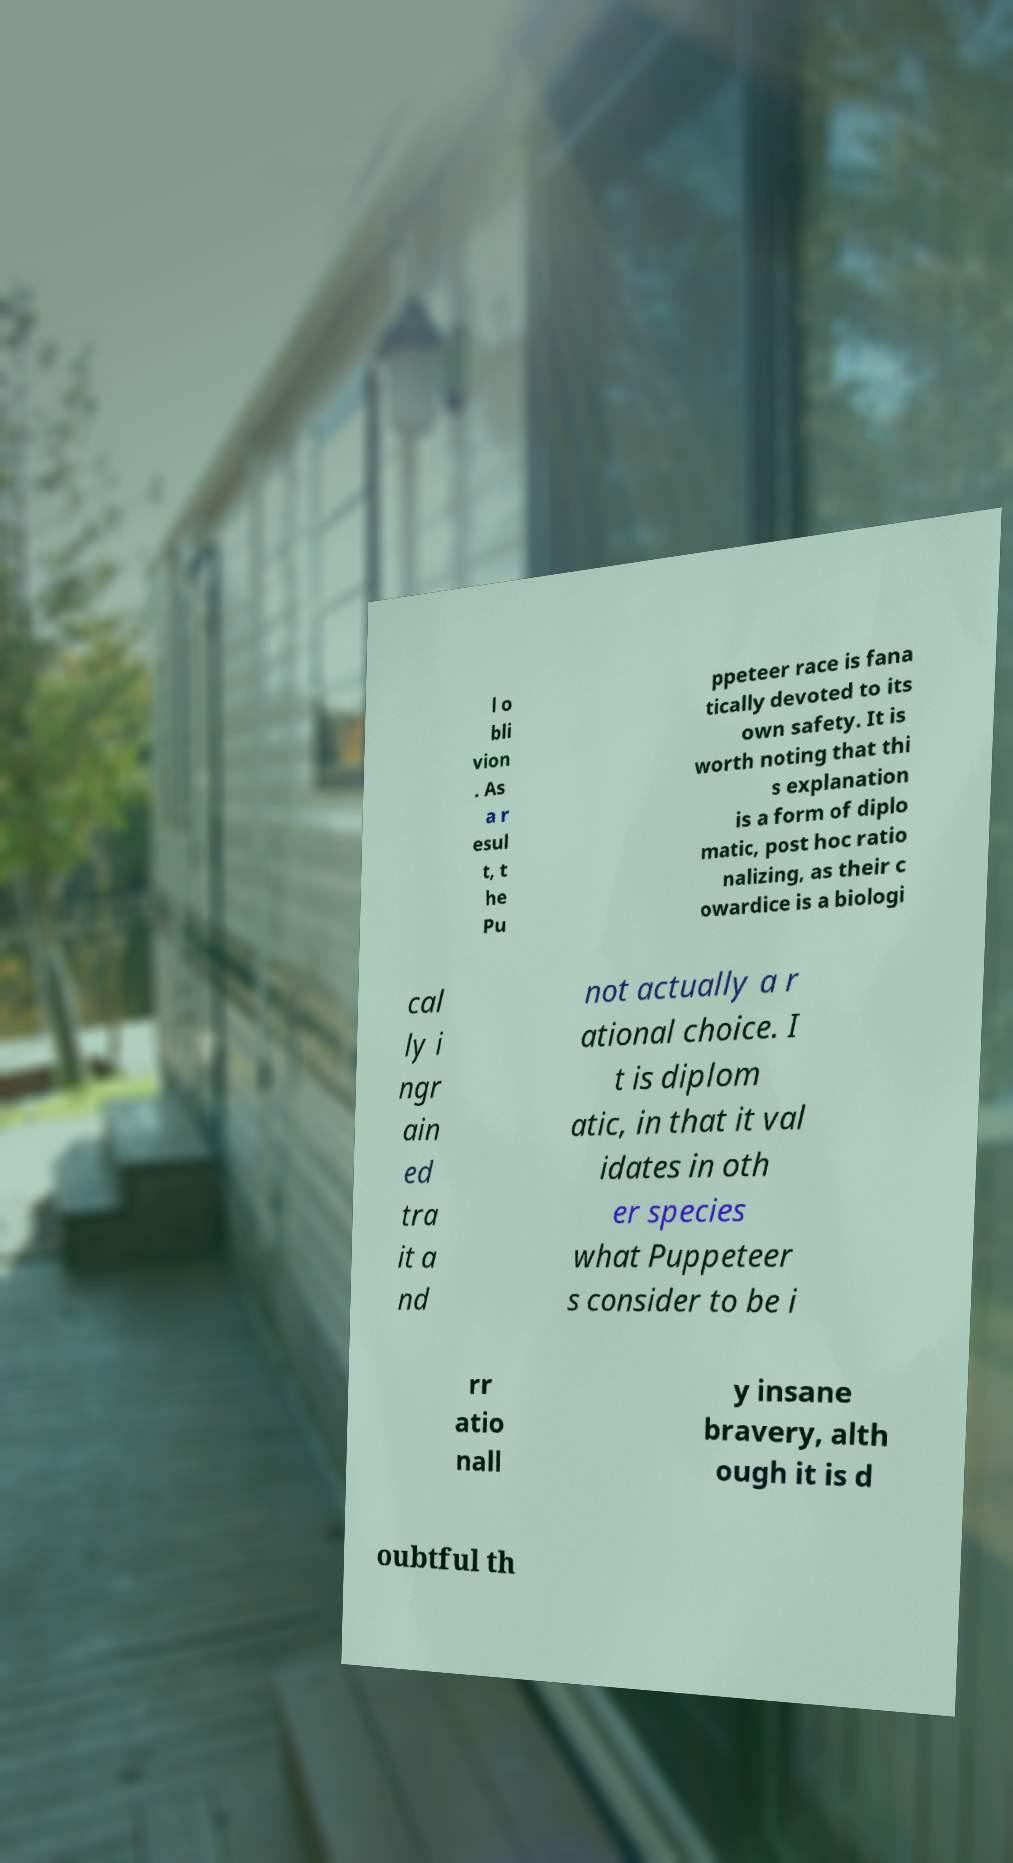What messages or text are displayed in this image? I need them in a readable, typed format. l o bli vion . As a r esul t, t he Pu ppeteer race is fana tically devoted to its own safety. It is worth noting that thi s explanation is a form of diplo matic, post hoc ratio nalizing, as their c owardice is a biologi cal ly i ngr ain ed tra it a nd not actually a r ational choice. I t is diplom atic, in that it val idates in oth er species what Puppeteer s consider to be i rr atio nall y insane bravery, alth ough it is d oubtful th 